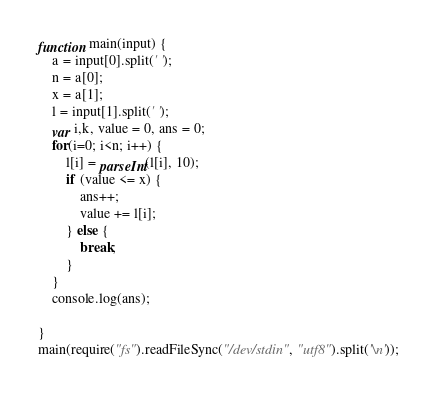<code> <loc_0><loc_0><loc_500><loc_500><_JavaScript_>function main(input) {
    a = input[0].split(' ');
    n = a[0];
    x = a[1];
    l = input[1].split(' ');
    var i,k, value = 0, ans = 0;
    for(i=0; i<n; i++) {
        l[i] = parseInt(l[i], 10);
        if (value <= x) {
            ans++;
            value += l[i];
        } else {
            break;
        }
    }
    console.log(ans);
    
}
main(require("fs").readFileSync("/dev/stdin", "utf8").split('\n'));</code> 